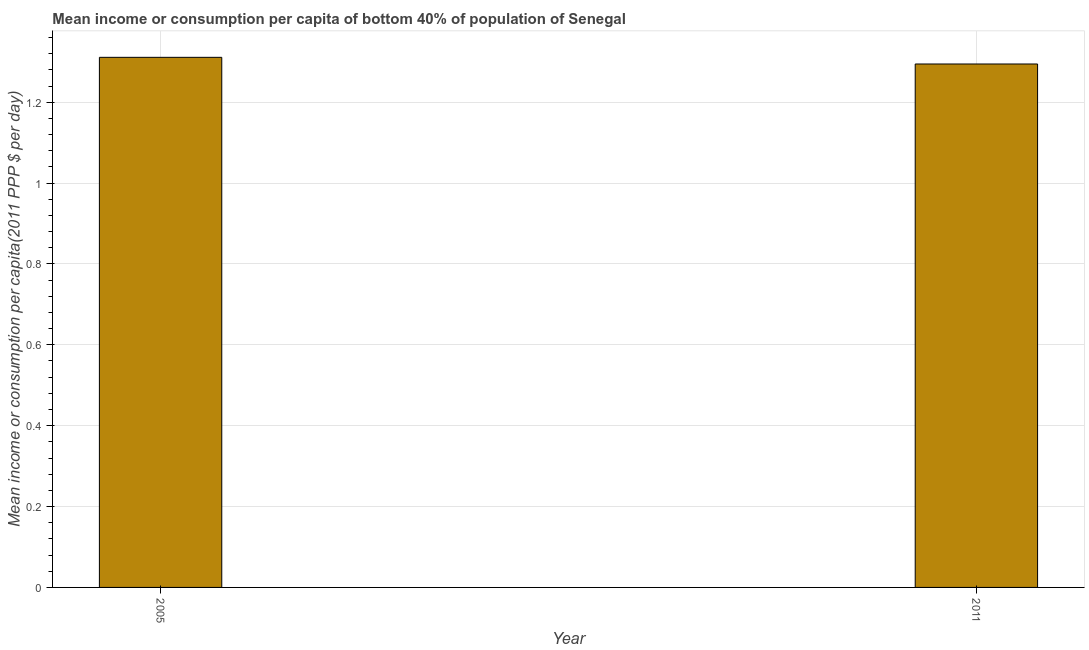Does the graph contain any zero values?
Provide a succinct answer. No. Does the graph contain grids?
Make the answer very short. Yes. What is the title of the graph?
Offer a terse response. Mean income or consumption per capita of bottom 40% of population of Senegal. What is the label or title of the Y-axis?
Provide a short and direct response. Mean income or consumption per capita(2011 PPP $ per day). What is the mean income or consumption in 2005?
Offer a very short reply. 1.31. Across all years, what is the maximum mean income or consumption?
Keep it short and to the point. 1.31. Across all years, what is the minimum mean income or consumption?
Keep it short and to the point. 1.29. In which year was the mean income or consumption minimum?
Provide a succinct answer. 2011. What is the sum of the mean income or consumption?
Provide a short and direct response. 2.61. What is the difference between the mean income or consumption in 2005 and 2011?
Offer a terse response. 0.02. What is the average mean income or consumption per year?
Make the answer very short. 1.3. What is the median mean income or consumption?
Your response must be concise. 1.3. What is the ratio of the mean income or consumption in 2005 to that in 2011?
Offer a very short reply. 1.01. Is the mean income or consumption in 2005 less than that in 2011?
Keep it short and to the point. No. In how many years, is the mean income or consumption greater than the average mean income or consumption taken over all years?
Your answer should be very brief. 1. Are the values on the major ticks of Y-axis written in scientific E-notation?
Give a very brief answer. No. What is the Mean income or consumption per capita(2011 PPP $ per day) in 2005?
Ensure brevity in your answer.  1.31. What is the Mean income or consumption per capita(2011 PPP $ per day) in 2011?
Provide a short and direct response. 1.29. What is the difference between the Mean income or consumption per capita(2011 PPP $ per day) in 2005 and 2011?
Keep it short and to the point. 0.02. 